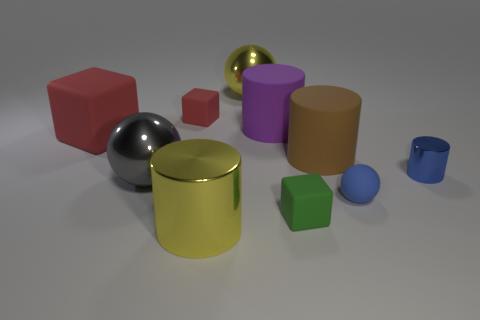Subtract all cubes. How many objects are left? 7 Add 8 tiny gray matte things. How many tiny gray matte things exist? 8 Subtract 0 blue cubes. How many objects are left? 10 Subtract all small cubes. Subtract all small blue things. How many objects are left? 6 Add 3 small balls. How many small balls are left? 4 